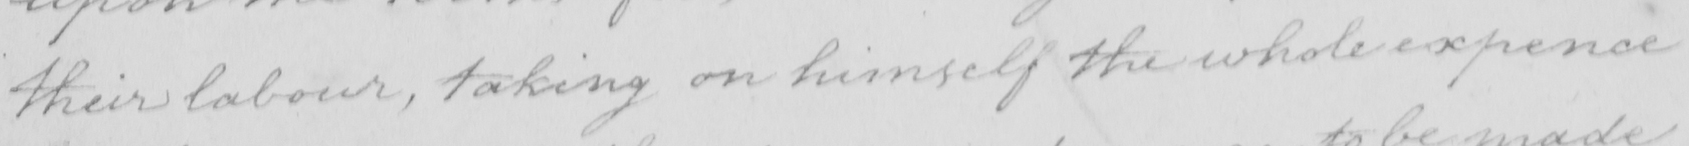What text is written in this handwritten line? their labour , taking on himself the whole expence 